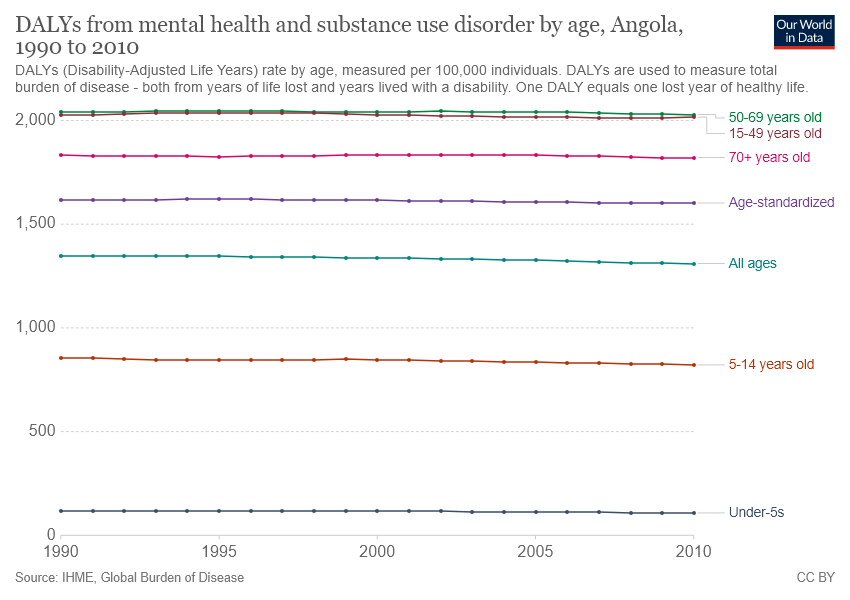Give some essential details in this illustration. The chart includes five age groups. 